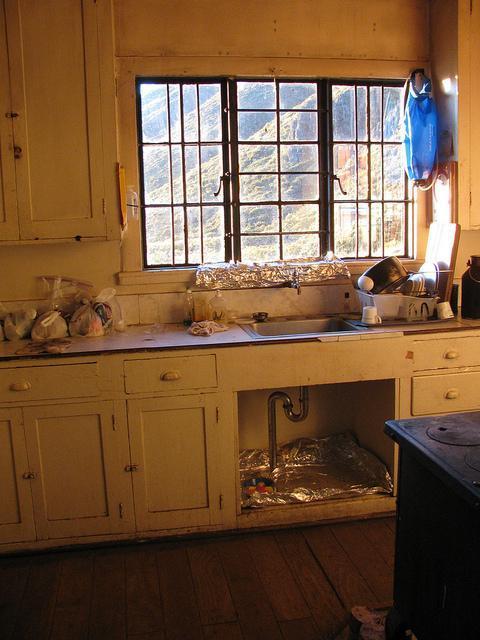How many people are holding tennis balls in the picture?
Give a very brief answer. 0. 